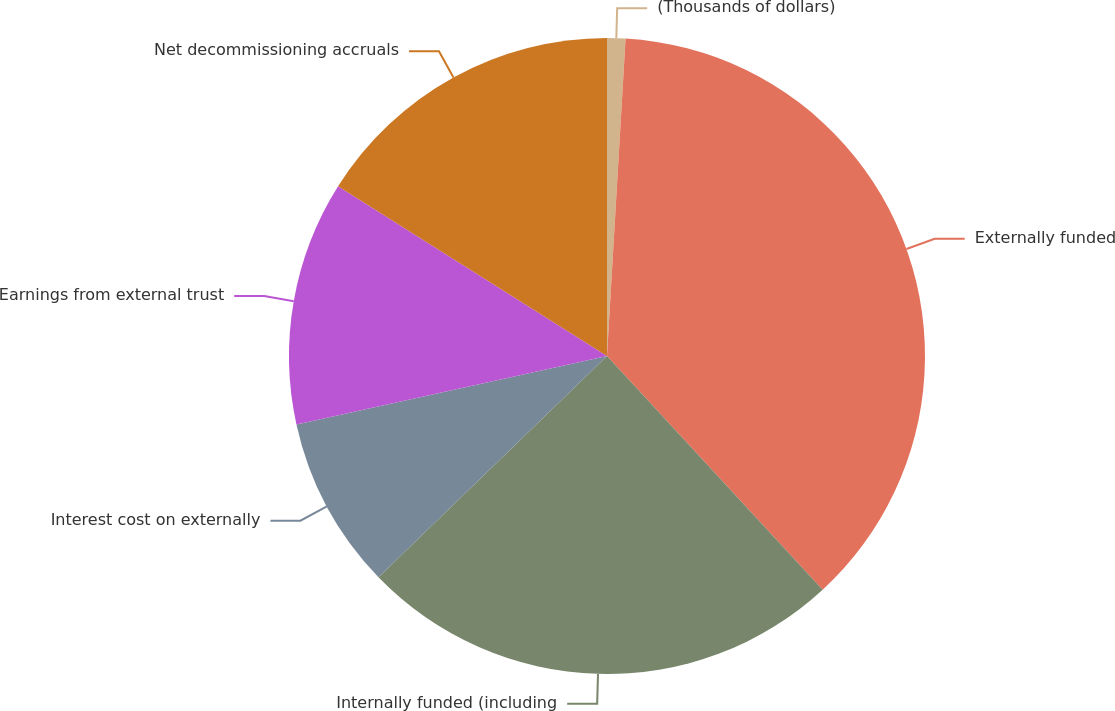Convert chart. <chart><loc_0><loc_0><loc_500><loc_500><pie_chart><fcel>(Thousands of dollars)<fcel>Externally funded<fcel>Internally funded (including<fcel>Interest cost on externally<fcel>Earnings from external trust<fcel>Net decommissioning accruals<nl><fcel>0.93%<fcel>37.21%<fcel>24.62%<fcel>8.79%<fcel>12.41%<fcel>16.04%<nl></chart> 